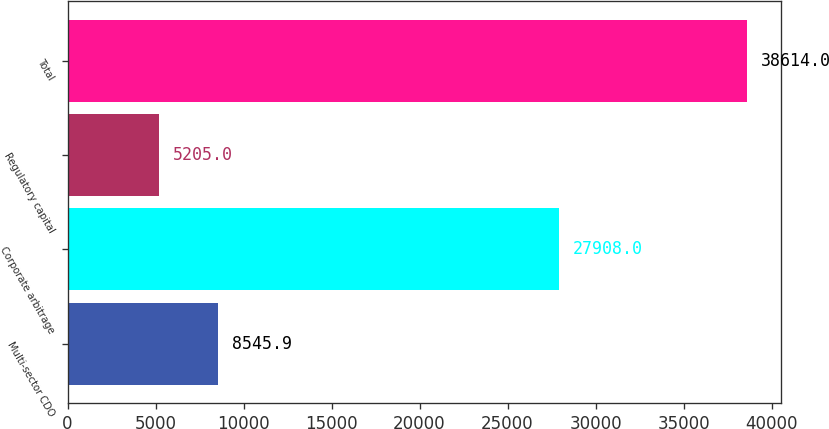Convert chart. <chart><loc_0><loc_0><loc_500><loc_500><bar_chart><fcel>Multi-sector CDO<fcel>Corporate arbitrage<fcel>Regulatory capital<fcel>Total<nl><fcel>8545.9<fcel>27908<fcel>5205<fcel>38614<nl></chart> 